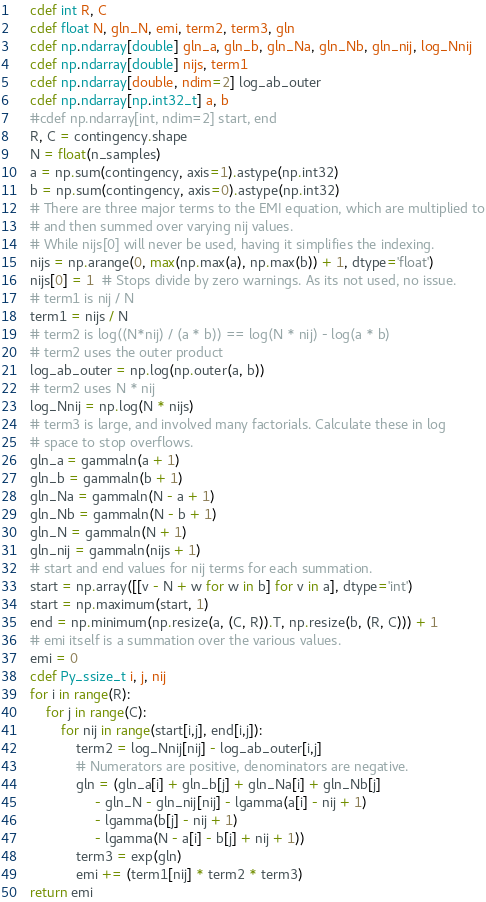<code> <loc_0><loc_0><loc_500><loc_500><_Cython_>    cdef int R, C
    cdef float N, gln_N, emi, term2, term3, gln
    cdef np.ndarray[double] gln_a, gln_b, gln_Na, gln_Nb, gln_nij, log_Nnij
    cdef np.ndarray[double] nijs, term1
    cdef np.ndarray[double, ndim=2] log_ab_outer
    cdef np.ndarray[np.int32_t] a, b
    #cdef np.ndarray[int, ndim=2] start, end
    R, C = contingency.shape
    N = float(n_samples)
    a = np.sum(contingency, axis=1).astype(np.int32)
    b = np.sum(contingency, axis=0).astype(np.int32)
    # There are three major terms to the EMI equation, which are multiplied to
    # and then summed over varying nij values.
    # While nijs[0] will never be used, having it simplifies the indexing.
    nijs = np.arange(0, max(np.max(a), np.max(b)) + 1, dtype='float')
    nijs[0] = 1  # Stops divide by zero warnings. As its not used, no issue.
    # term1 is nij / N
    term1 = nijs / N
    # term2 is log((N*nij) / (a * b)) == log(N * nij) - log(a * b)
    # term2 uses the outer product
    log_ab_outer = np.log(np.outer(a, b))
    # term2 uses N * nij
    log_Nnij = np.log(N * nijs)
    # term3 is large, and involved many factorials. Calculate these in log
    # space to stop overflows.
    gln_a = gammaln(a + 1)
    gln_b = gammaln(b + 1)
    gln_Na = gammaln(N - a + 1)
    gln_Nb = gammaln(N - b + 1)
    gln_N = gammaln(N + 1)
    gln_nij = gammaln(nijs + 1)
    # start and end values for nij terms for each summation.
    start = np.array([[v - N + w for w in b] for v in a], dtype='int')
    start = np.maximum(start, 1)
    end = np.minimum(np.resize(a, (C, R)).T, np.resize(b, (R, C))) + 1
    # emi itself is a summation over the various values.
    emi = 0
    cdef Py_ssize_t i, j, nij
    for i in range(R):
        for j in range(C):
            for nij in range(start[i,j], end[i,j]):
                term2 = log_Nnij[nij] - log_ab_outer[i,j]
                # Numerators are positive, denominators are negative.
                gln = (gln_a[i] + gln_b[j] + gln_Na[i] + gln_Nb[j]
                     - gln_N - gln_nij[nij] - lgamma(a[i] - nij + 1)
                     - lgamma(b[j] - nij + 1)
                     - lgamma(N - a[i] - b[j] + nij + 1))
                term3 = exp(gln)
                emi += (term1[nij] * term2 * term3)
    return emi
</code> 